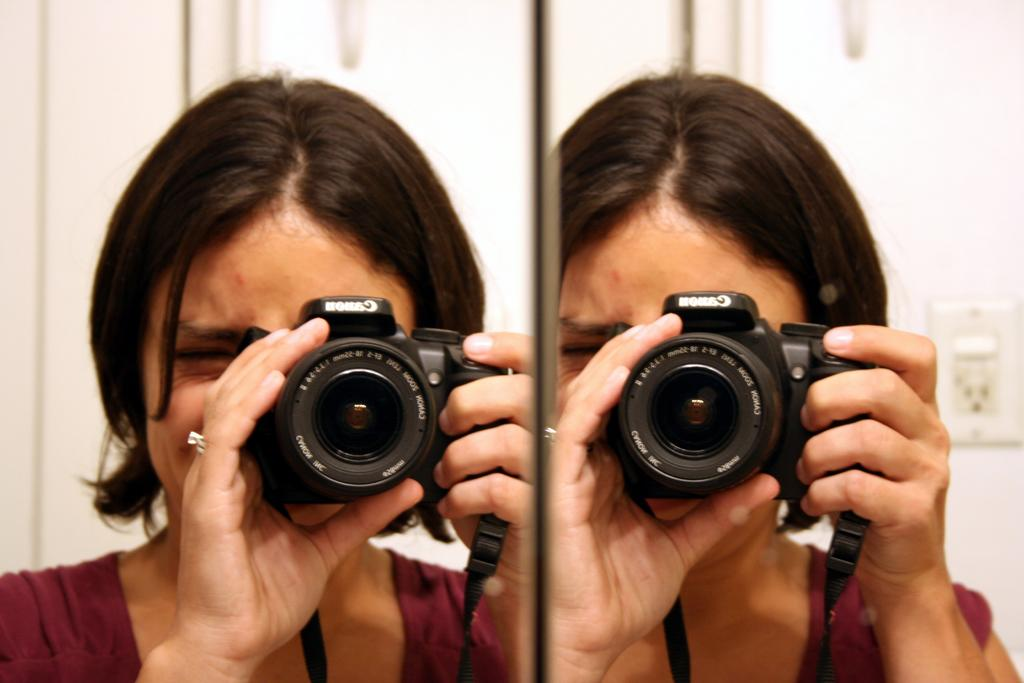Who is the main subject in the image? There is a lady in the image. What is the lady holding in the image? The lady is holding a camera. What is the lady doing with the camera? The lady is clicking pictures. What can be seen in the background of the image? There is a switch board in the background of the image. Reasoning: Let' Let's think step by step in order to produce the conversation. We start by identifying the main subject in the image, which is the lady. Then, we describe what the lady is holding and doing, which is a camera and clicking pictures. Finally, we mention the background element, which is the switch board. Each question is designed to elicit a specific detail about the image that is known from the provided facts. Absurd Question/Answer: Where is the ladybug in the image? There is no ladybug present in the image. What type of playground can be seen in the background of the image? There is no playground present in the image; it features a lady holding a camera and a switch board in the background. What type of cover is protecting the lady from the sun in the image? There is no cover present in the image to protect the lady from the sun. 